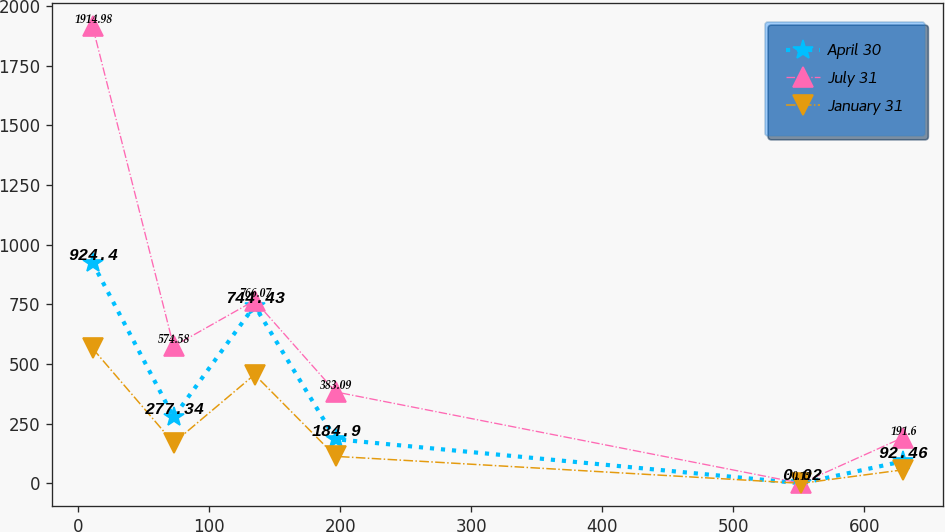Convert chart to OTSL. <chart><loc_0><loc_0><loc_500><loc_500><line_chart><ecel><fcel>April 30<fcel>July 31<fcel>January 31<nl><fcel>10.94<fcel>924.4<fcel>1914.98<fcel>565.23<nl><fcel>72.78<fcel>277.34<fcel>574.58<fcel>169.62<nl><fcel>134.62<fcel>744.43<fcel>766.07<fcel>455.73<nl><fcel>196.47<fcel>184.9<fcel>383.09<fcel>113.11<nl><fcel>551.89<fcel>0.02<fcel>0.11<fcel>0.09<nl><fcel>629.39<fcel>92.46<fcel>191.6<fcel>56.6<nl></chart> 